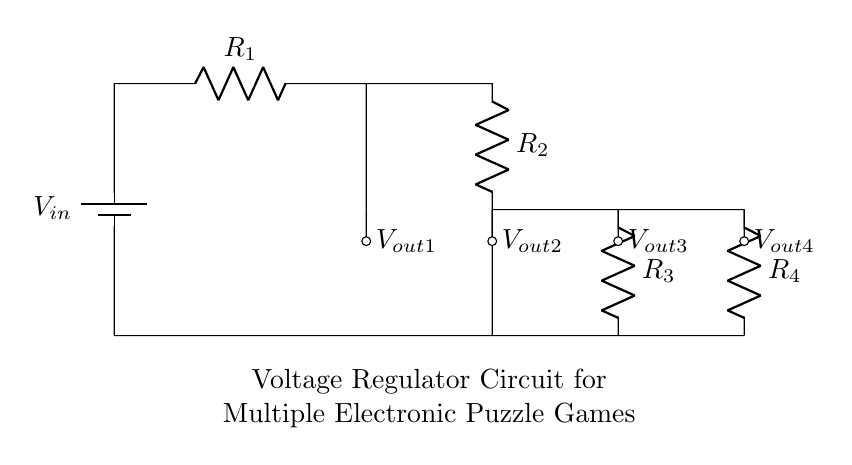What is the input voltage for the circuit? The input voltage is labeled as V_in, which is the voltage source providing power to the entire network of resistors.
Answer: V_in How many resistors are present in the circuit? The circuit contains four resistors labeled as R_1, R_2, R_3, and R_4, which are connected in such a way to form a voltage divider.
Answer: 4 What are the output voltages labeled in the circuit? The output voltages are labeled as V_out1, V_out2, V_out3, and V_out4, indicating the voltage measured across the respective resistors R_1, R_2, R_3, and R_4.
Answer: V_out1, V_out2, V_out3, V_out4 What happens to voltage across consecutive resistors? In a voltage divider, the voltage across each subsequent resistor decreases according to the ratio of the resistor values, distributing the total input voltage proportionally.
Answer: Decreases If the resistance of R_1 is doubled, what happens to V_out1? Doubling the resistance R_1 increases the voltage drop across it, thus increasing V_out1 since it is directly across R_1, leading to a higher output voltage from that resistor.
Answer: Increases 